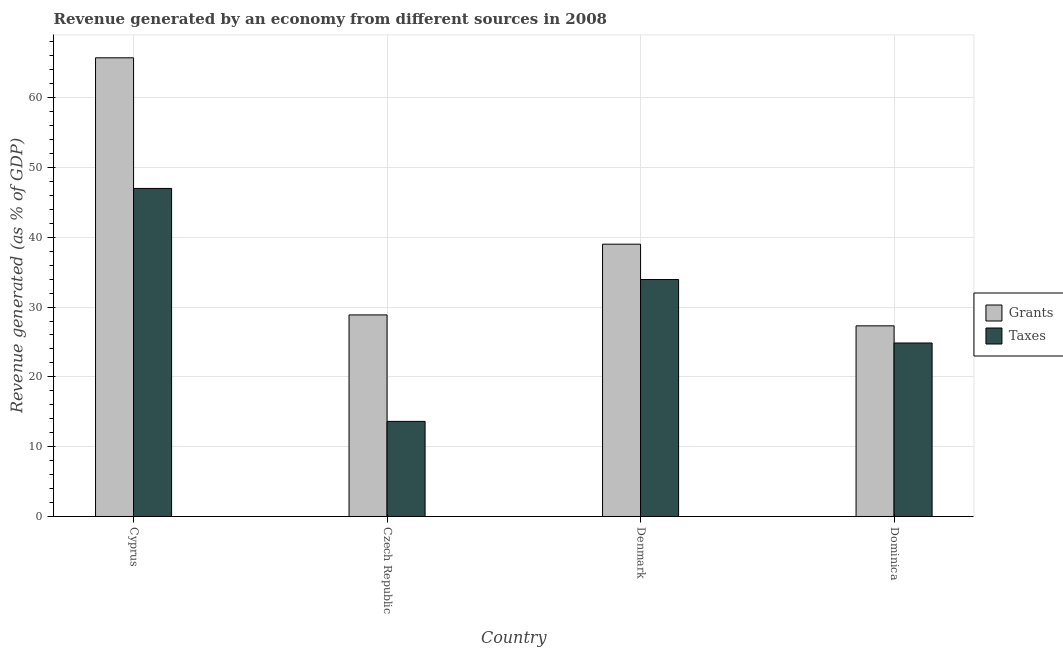Are the number of bars on each tick of the X-axis equal?
Your answer should be very brief. Yes. How many bars are there on the 1st tick from the left?
Provide a short and direct response. 2. How many bars are there on the 3rd tick from the right?
Offer a terse response. 2. In how many cases, is the number of bars for a given country not equal to the number of legend labels?
Provide a succinct answer. 0. What is the revenue generated by grants in Dominica?
Provide a short and direct response. 27.31. Across all countries, what is the maximum revenue generated by grants?
Keep it short and to the point. 65.7. Across all countries, what is the minimum revenue generated by grants?
Offer a terse response. 27.31. In which country was the revenue generated by grants maximum?
Your answer should be very brief. Cyprus. In which country was the revenue generated by grants minimum?
Your answer should be very brief. Dominica. What is the total revenue generated by taxes in the graph?
Keep it short and to the point. 119.4. What is the difference between the revenue generated by grants in Cyprus and that in Czech Republic?
Keep it short and to the point. 36.83. What is the difference between the revenue generated by taxes in Dominica and the revenue generated by grants in Czech Republic?
Offer a terse response. -4.02. What is the average revenue generated by taxes per country?
Your response must be concise. 29.85. What is the difference between the revenue generated by grants and revenue generated by taxes in Dominica?
Your response must be concise. 2.46. In how many countries, is the revenue generated by grants greater than 46 %?
Keep it short and to the point. 1. What is the ratio of the revenue generated by grants in Cyprus to that in Dominica?
Offer a terse response. 2.41. Is the revenue generated by taxes in Czech Republic less than that in Dominica?
Your answer should be very brief. Yes. Is the difference between the revenue generated by grants in Cyprus and Czech Republic greater than the difference between the revenue generated by taxes in Cyprus and Czech Republic?
Ensure brevity in your answer.  Yes. What is the difference between the highest and the second highest revenue generated by taxes?
Keep it short and to the point. 13.04. What is the difference between the highest and the lowest revenue generated by taxes?
Keep it short and to the point. 33.37. What does the 1st bar from the left in Cyprus represents?
Your answer should be compact. Grants. What does the 2nd bar from the right in Czech Republic represents?
Your answer should be very brief. Grants. Are all the bars in the graph horizontal?
Ensure brevity in your answer.  No. How many countries are there in the graph?
Make the answer very short. 4. What is the difference between two consecutive major ticks on the Y-axis?
Provide a short and direct response. 10. Does the graph contain any zero values?
Ensure brevity in your answer.  No. Where does the legend appear in the graph?
Provide a succinct answer. Center right. How many legend labels are there?
Make the answer very short. 2. What is the title of the graph?
Offer a terse response. Revenue generated by an economy from different sources in 2008. Does "Current education expenditure" appear as one of the legend labels in the graph?
Offer a terse response. No. What is the label or title of the X-axis?
Your response must be concise. Country. What is the label or title of the Y-axis?
Ensure brevity in your answer.  Revenue generated (as % of GDP). What is the Revenue generated (as % of GDP) of Grants in Cyprus?
Keep it short and to the point. 65.7. What is the Revenue generated (as % of GDP) of Taxes in Cyprus?
Offer a very short reply. 46.99. What is the Revenue generated (as % of GDP) of Grants in Czech Republic?
Offer a terse response. 28.87. What is the Revenue generated (as % of GDP) in Taxes in Czech Republic?
Your answer should be compact. 13.62. What is the Revenue generated (as % of GDP) in Grants in Denmark?
Provide a short and direct response. 39.01. What is the Revenue generated (as % of GDP) in Taxes in Denmark?
Your answer should be very brief. 33.94. What is the Revenue generated (as % of GDP) of Grants in Dominica?
Offer a very short reply. 27.31. What is the Revenue generated (as % of GDP) of Taxes in Dominica?
Offer a very short reply. 24.85. Across all countries, what is the maximum Revenue generated (as % of GDP) of Grants?
Make the answer very short. 65.7. Across all countries, what is the maximum Revenue generated (as % of GDP) of Taxes?
Your response must be concise. 46.99. Across all countries, what is the minimum Revenue generated (as % of GDP) in Grants?
Your answer should be very brief. 27.31. Across all countries, what is the minimum Revenue generated (as % of GDP) of Taxes?
Offer a terse response. 13.62. What is the total Revenue generated (as % of GDP) of Grants in the graph?
Offer a very short reply. 160.89. What is the total Revenue generated (as % of GDP) in Taxes in the graph?
Give a very brief answer. 119.4. What is the difference between the Revenue generated (as % of GDP) of Grants in Cyprus and that in Czech Republic?
Your response must be concise. 36.83. What is the difference between the Revenue generated (as % of GDP) of Taxes in Cyprus and that in Czech Republic?
Your response must be concise. 33.37. What is the difference between the Revenue generated (as % of GDP) in Grants in Cyprus and that in Denmark?
Your response must be concise. 26.7. What is the difference between the Revenue generated (as % of GDP) of Taxes in Cyprus and that in Denmark?
Your answer should be very brief. 13.04. What is the difference between the Revenue generated (as % of GDP) of Grants in Cyprus and that in Dominica?
Ensure brevity in your answer.  38.39. What is the difference between the Revenue generated (as % of GDP) in Taxes in Cyprus and that in Dominica?
Keep it short and to the point. 22.14. What is the difference between the Revenue generated (as % of GDP) of Grants in Czech Republic and that in Denmark?
Your answer should be compact. -10.13. What is the difference between the Revenue generated (as % of GDP) of Taxes in Czech Republic and that in Denmark?
Ensure brevity in your answer.  -20.32. What is the difference between the Revenue generated (as % of GDP) of Grants in Czech Republic and that in Dominica?
Give a very brief answer. 1.57. What is the difference between the Revenue generated (as % of GDP) of Taxes in Czech Republic and that in Dominica?
Keep it short and to the point. -11.23. What is the difference between the Revenue generated (as % of GDP) of Grants in Denmark and that in Dominica?
Ensure brevity in your answer.  11.7. What is the difference between the Revenue generated (as % of GDP) in Taxes in Denmark and that in Dominica?
Make the answer very short. 9.09. What is the difference between the Revenue generated (as % of GDP) of Grants in Cyprus and the Revenue generated (as % of GDP) of Taxes in Czech Republic?
Provide a succinct answer. 52.08. What is the difference between the Revenue generated (as % of GDP) in Grants in Cyprus and the Revenue generated (as % of GDP) in Taxes in Denmark?
Provide a short and direct response. 31.76. What is the difference between the Revenue generated (as % of GDP) of Grants in Cyprus and the Revenue generated (as % of GDP) of Taxes in Dominica?
Provide a short and direct response. 40.85. What is the difference between the Revenue generated (as % of GDP) in Grants in Czech Republic and the Revenue generated (as % of GDP) in Taxes in Denmark?
Your answer should be compact. -5.07. What is the difference between the Revenue generated (as % of GDP) of Grants in Czech Republic and the Revenue generated (as % of GDP) of Taxes in Dominica?
Ensure brevity in your answer.  4.02. What is the difference between the Revenue generated (as % of GDP) in Grants in Denmark and the Revenue generated (as % of GDP) in Taxes in Dominica?
Make the answer very short. 14.16. What is the average Revenue generated (as % of GDP) in Grants per country?
Provide a short and direct response. 40.22. What is the average Revenue generated (as % of GDP) of Taxes per country?
Ensure brevity in your answer.  29.85. What is the difference between the Revenue generated (as % of GDP) in Grants and Revenue generated (as % of GDP) in Taxes in Cyprus?
Provide a succinct answer. 18.71. What is the difference between the Revenue generated (as % of GDP) of Grants and Revenue generated (as % of GDP) of Taxes in Czech Republic?
Provide a short and direct response. 15.25. What is the difference between the Revenue generated (as % of GDP) in Grants and Revenue generated (as % of GDP) in Taxes in Denmark?
Provide a short and direct response. 5.06. What is the difference between the Revenue generated (as % of GDP) of Grants and Revenue generated (as % of GDP) of Taxes in Dominica?
Your answer should be very brief. 2.46. What is the ratio of the Revenue generated (as % of GDP) of Grants in Cyprus to that in Czech Republic?
Offer a terse response. 2.28. What is the ratio of the Revenue generated (as % of GDP) of Taxes in Cyprus to that in Czech Republic?
Your response must be concise. 3.45. What is the ratio of the Revenue generated (as % of GDP) of Grants in Cyprus to that in Denmark?
Offer a very short reply. 1.68. What is the ratio of the Revenue generated (as % of GDP) of Taxes in Cyprus to that in Denmark?
Your answer should be very brief. 1.38. What is the ratio of the Revenue generated (as % of GDP) of Grants in Cyprus to that in Dominica?
Your answer should be compact. 2.41. What is the ratio of the Revenue generated (as % of GDP) of Taxes in Cyprus to that in Dominica?
Your response must be concise. 1.89. What is the ratio of the Revenue generated (as % of GDP) in Grants in Czech Republic to that in Denmark?
Provide a short and direct response. 0.74. What is the ratio of the Revenue generated (as % of GDP) of Taxes in Czech Republic to that in Denmark?
Offer a very short reply. 0.4. What is the ratio of the Revenue generated (as % of GDP) of Grants in Czech Republic to that in Dominica?
Ensure brevity in your answer.  1.06. What is the ratio of the Revenue generated (as % of GDP) in Taxes in Czech Republic to that in Dominica?
Provide a succinct answer. 0.55. What is the ratio of the Revenue generated (as % of GDP) in Grants in Denmark to that in Dominica?
Offer a very short reply. 1.43. What is the ratio of the Revenue generated (as % of GDP) in Taxes in Denmark to that in Dominica?
Provide a short and direct response. 1.37. What is the difference between the highest and the second highest Revenue generated (as % of GDP) of Grants?
Make the answer very short. 26.7. What is the difference between the highest and the second highest Revenue generated (as % of GDP) of Taxes?
Your answer should be very brief. 13.04. What is the difference between the highest and the lowest Revenue generated (as % of GDP) in Grants?
Provide a succinct answer. 38.39. What is the difference between the highest and the lowest Revenue generated (as % of GDP) in Taxes?
Provide a short and direct response. 33.37. 